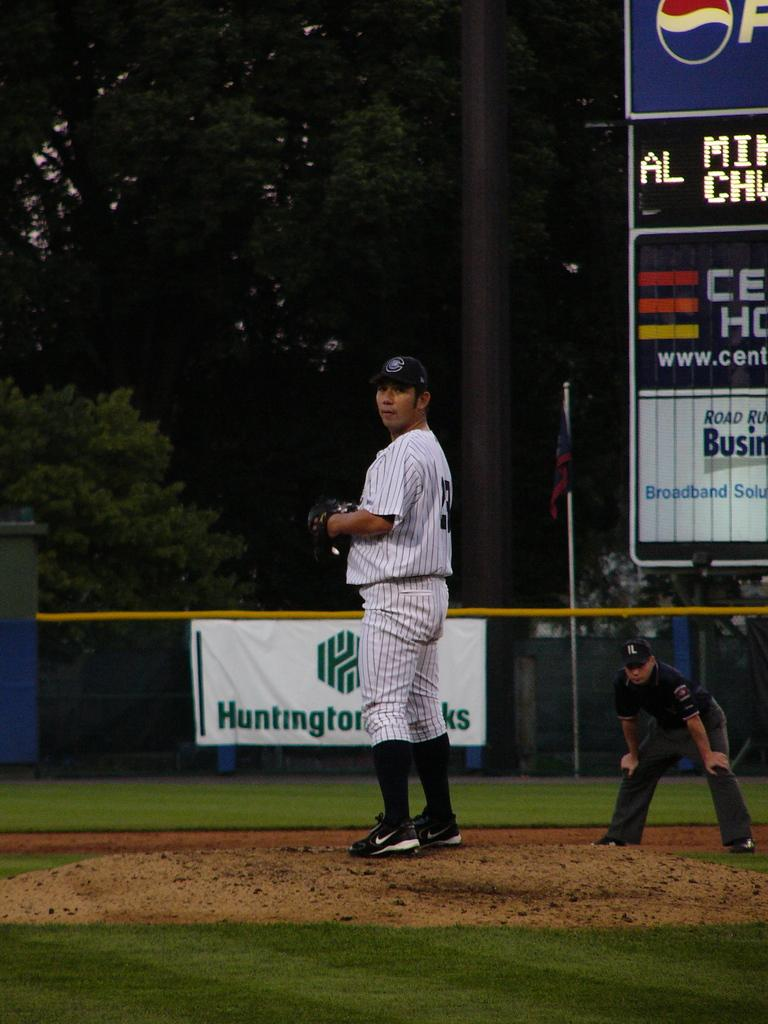<image>
Present a compact description of the photo's key features. A few baseball players are playing on a field with advertisements for Pepsi and a Broadband Solutions company 